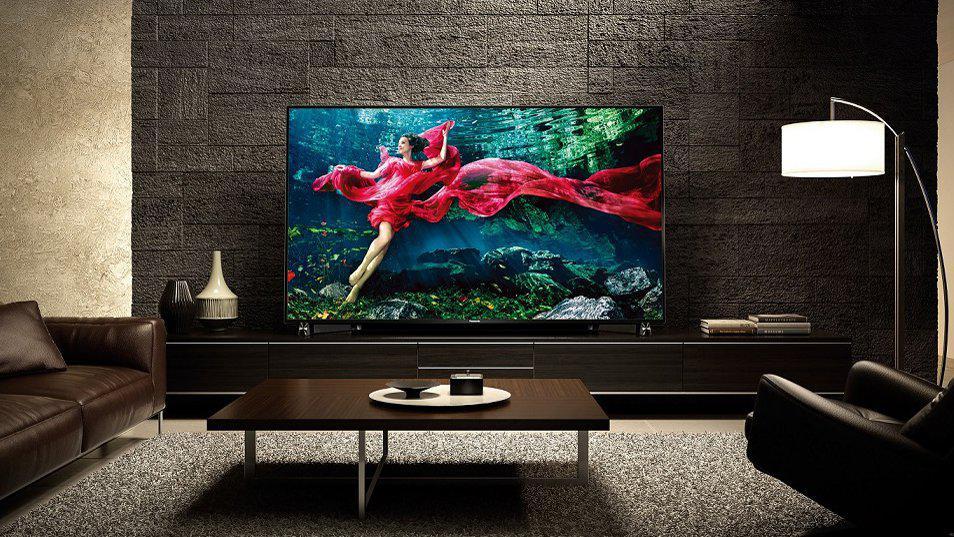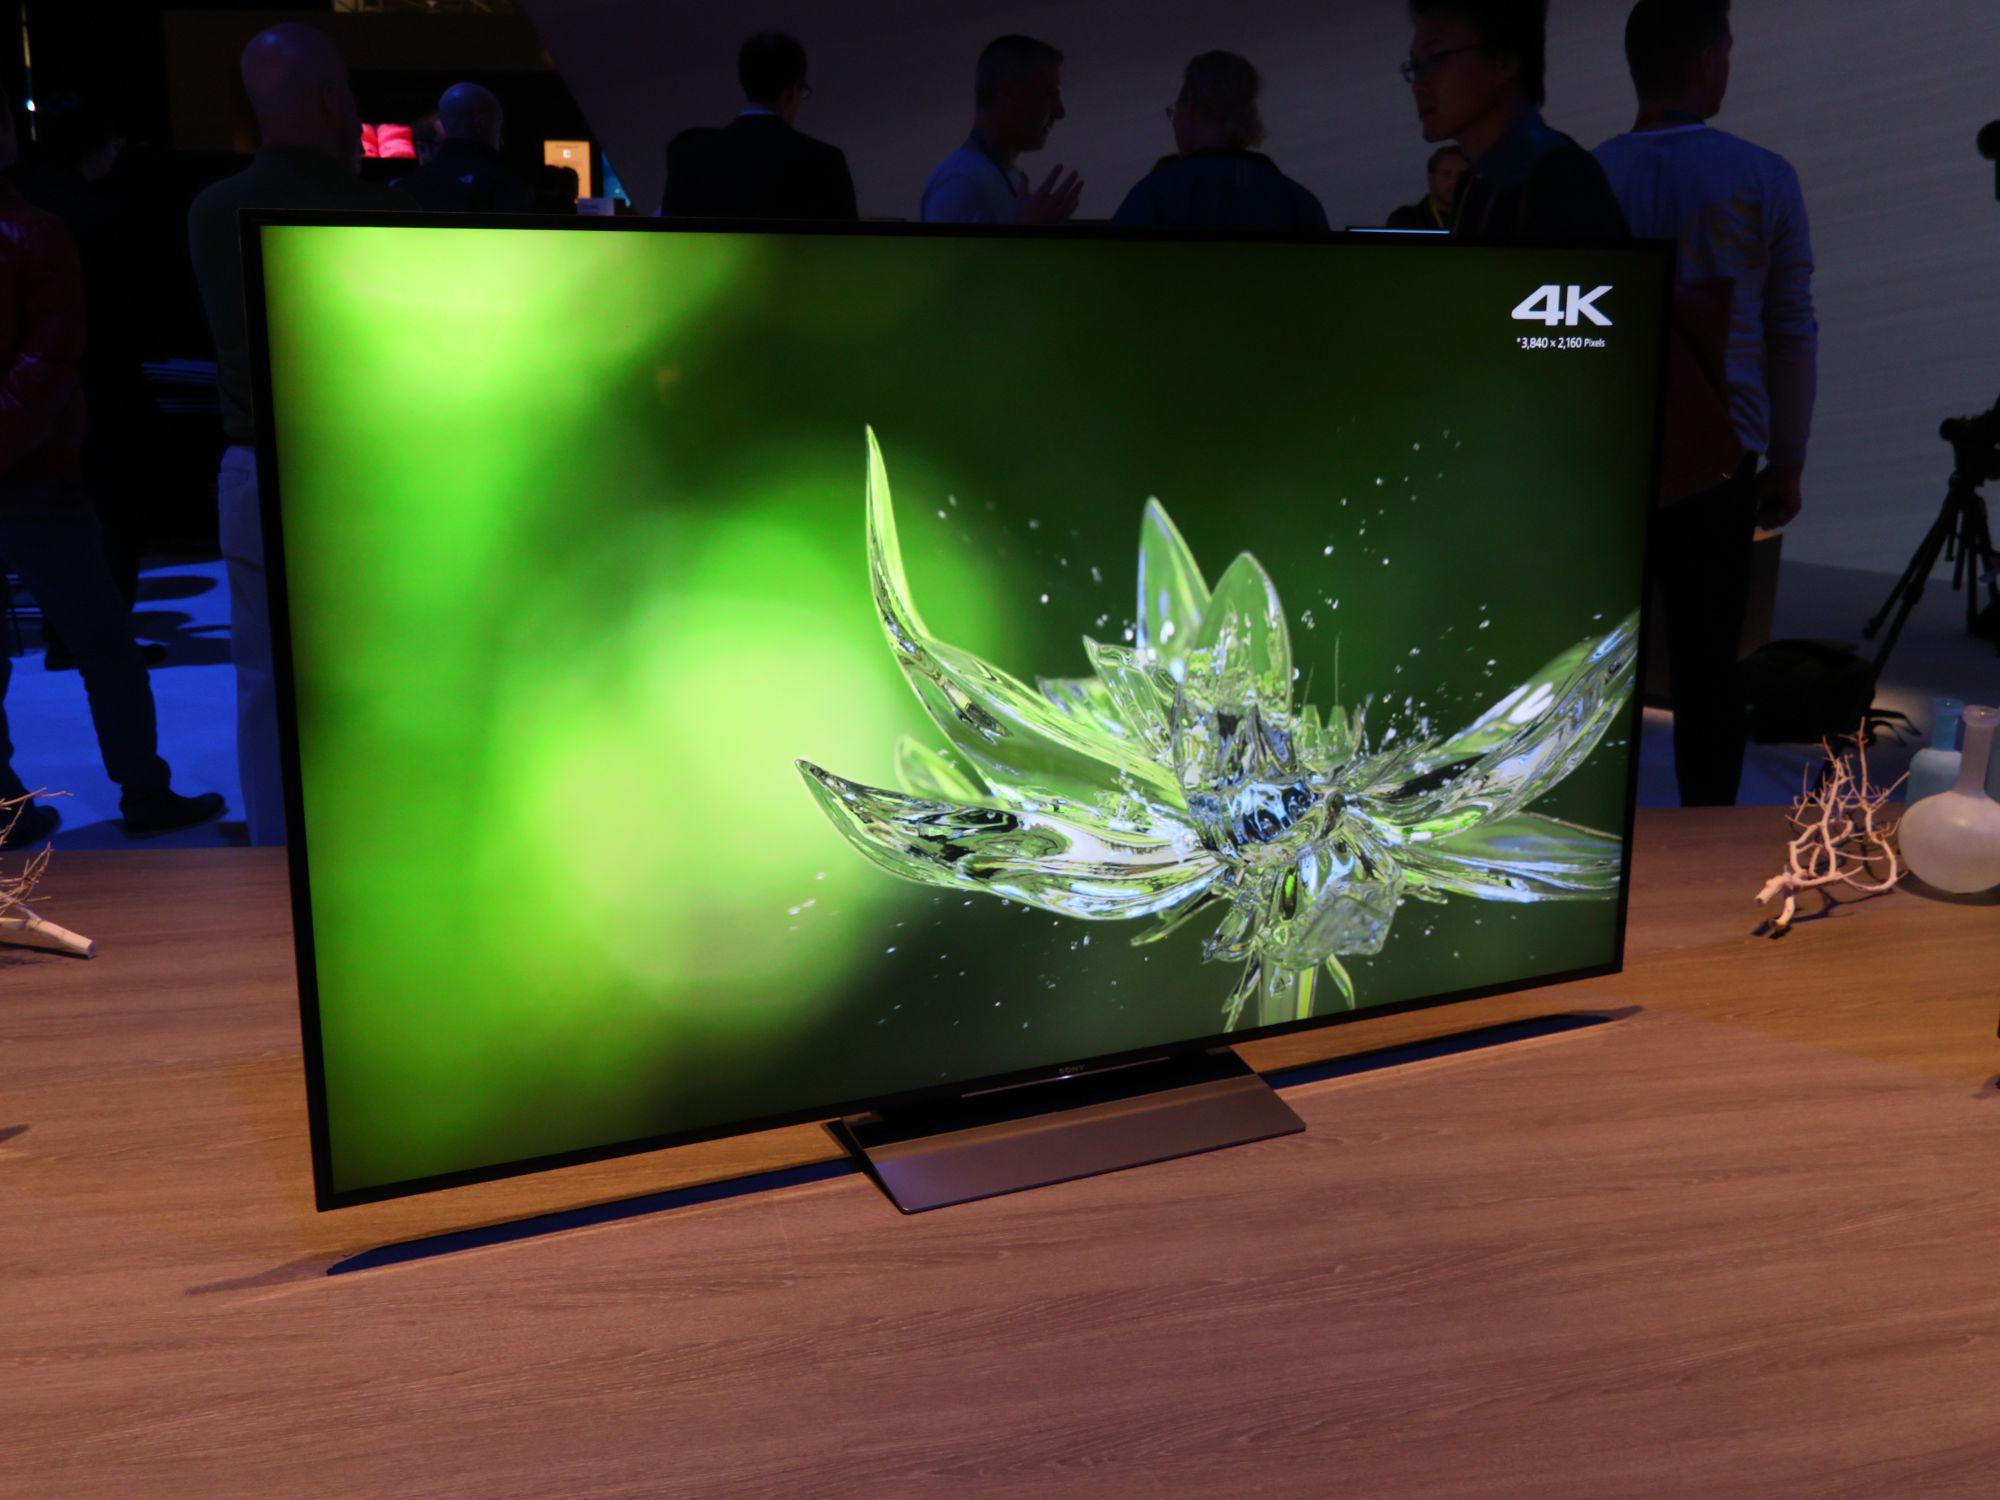The first image is the image on the left, the second image is the image on the right. Evaluate the accuracy of this statement regarding the images: "One of the televisions is in front of a bricked wall.". Is it true? Answer yes or no. Yes. The first image is the image on the left, the second image is the image on the right. Given the left and right images, does the statement "The right image contains more screened devices than the left image." hold true? Answer yes or no. No. 